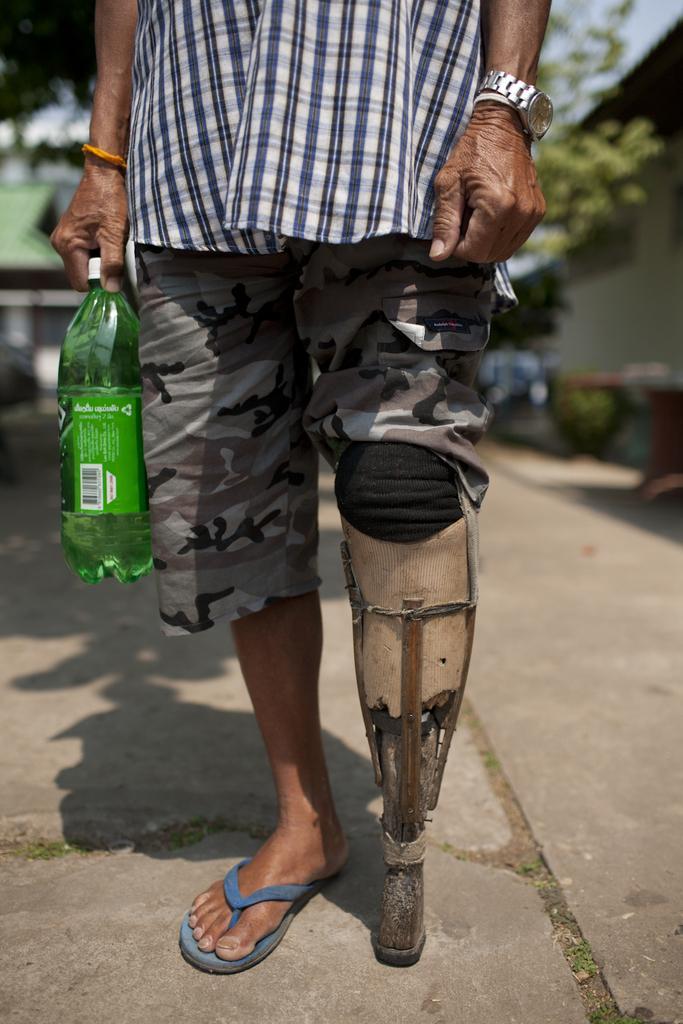Can you describe this image briefly? In the image we can see there is a person who is standing and holding green colour water bottle in his hand. 